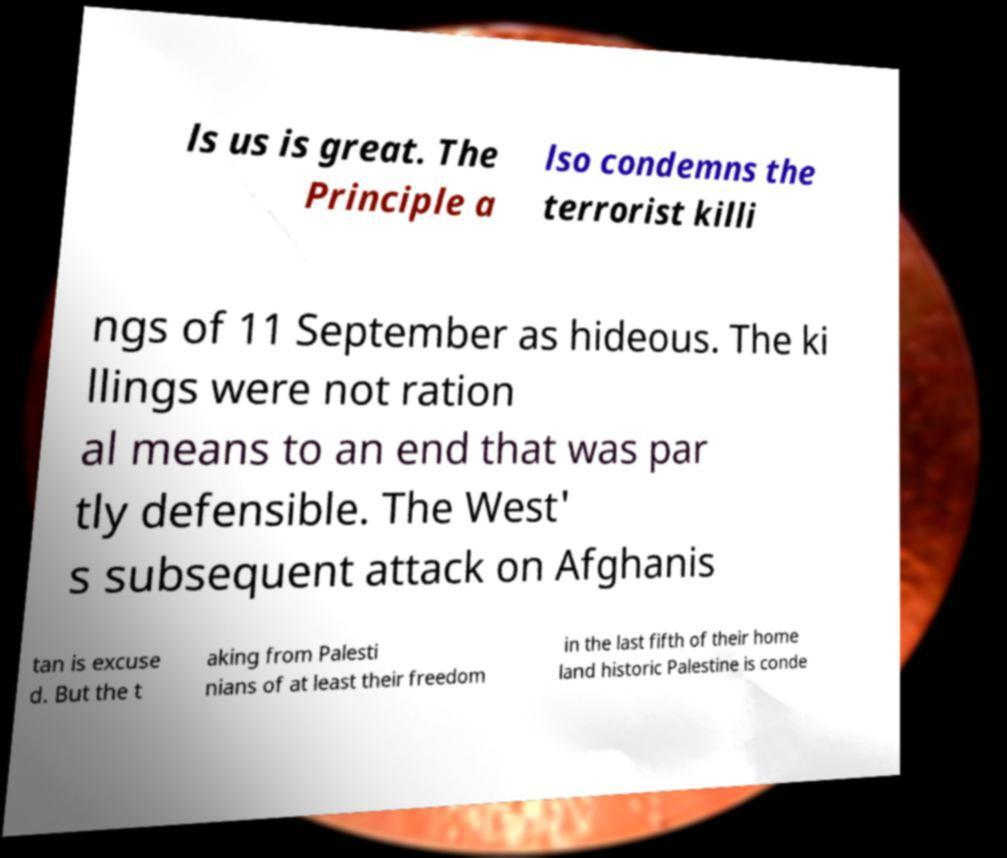Please identify and transcribe the text found in this image. ls us is great. The Principle a lso condemns the terrorist killi ngs of 11 September as hideous. The ki llings were not ration al means to an end that was par tly defensible. The West' s subsequent attack on Afghanis tan is excuse d. But the t aking from Palesti nians of at least their freedom in the last fifth of their home land historic Palestine is conde 